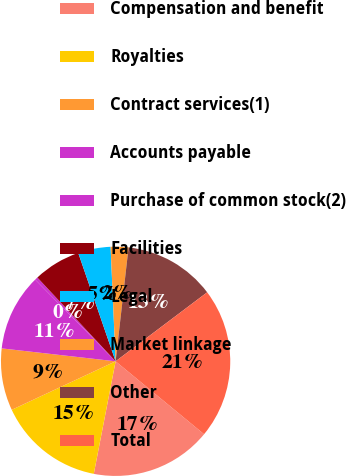Convert chart. <chart><loc_0><loc_0><loc_500><loc_500><pie_chart><fcel>Compensation and benefit<fcel>Royalties<fcel>Contract services(1)<fcel>Accounts payable<fcel>Purchase of common stock(2)<fcel>Facilities<fcel>Legal<fcel>Market linkage<fcel>Other<fcel>Total<nl><fcel>17.08%<fcel>15.0%<fcel>8.75%<fcel>10.83%<fcel>0.42%<fcel>6.67%<fcel>4.59%<fcel>2.5%<fcel>12.92%<fcel>21.25%<nl></chart> 